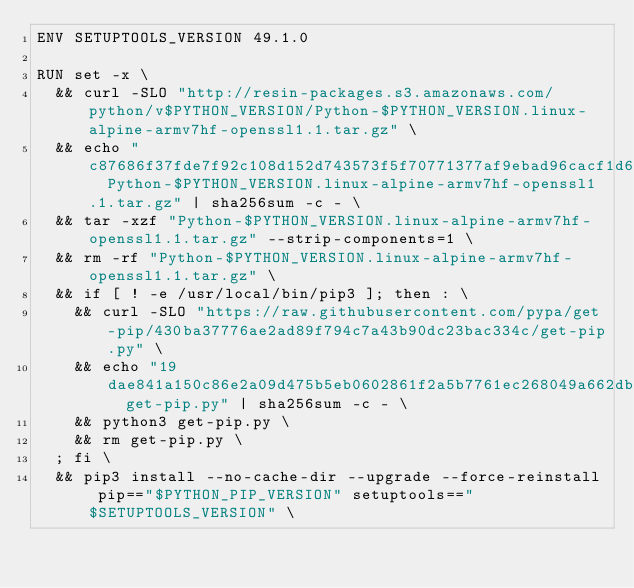Convert code to text. <code><loc_0><loc_0><loc_500><loc_500><_Dockerfile_>ENV SETUPTOOLS_VERSION 49.1.0

RUN set -x \
	&& curl -SLO "http://resin-packages.s3.amazonaws.com/python/v$PYTHON_VERSION/Python-$PYTHON_VERSION.linux-alpine-armv7hf-openssl1.1.tar.gz" \
	&& echo "c87686f37fde7f92c108d152d743573f5f70771377af9ebad96cacf1d6f444cc  Python-$PYTHON_VERSION.linux-alpine-armv7hf-openssl1.1.tar.gz" | sha256sum -c - \
	&& tar -xzf "Python-$PYTHON_VERSION.linux-alpine-armv7hf-openssl1.1.tar.gz" --strip-components=1 \
	&& rm -rf "Python-$PYTHON_VERSION.linux-alpine-armv7hf-openssl1.1.tar.gz" \
	&& if [ ! -e /usr/local/bin/pip3 ]; then : \
		&& curl -SLO "https://raw.githubusercontent.com/pypa/get-pip/430ba37776ae2ad89f794c7a43b90dc23bac334c/get-pip.py" \
		&& echo "19dae841a150c86e2a09d475b5eb0602861f2a5b7761ec268049a662dbd2bd0c  get-pip.py" | sha256sum -c - \
		&& python3 get-pip.py \
		&& rm get-pip.py \
	; fi \
	&& pip3 install --no-cache-dir --upgrade --force-reinstall pip=="$PYTHON_PIP_VERSION" setuptools=="$SETUPTOOLS_VERSION" \</code> 